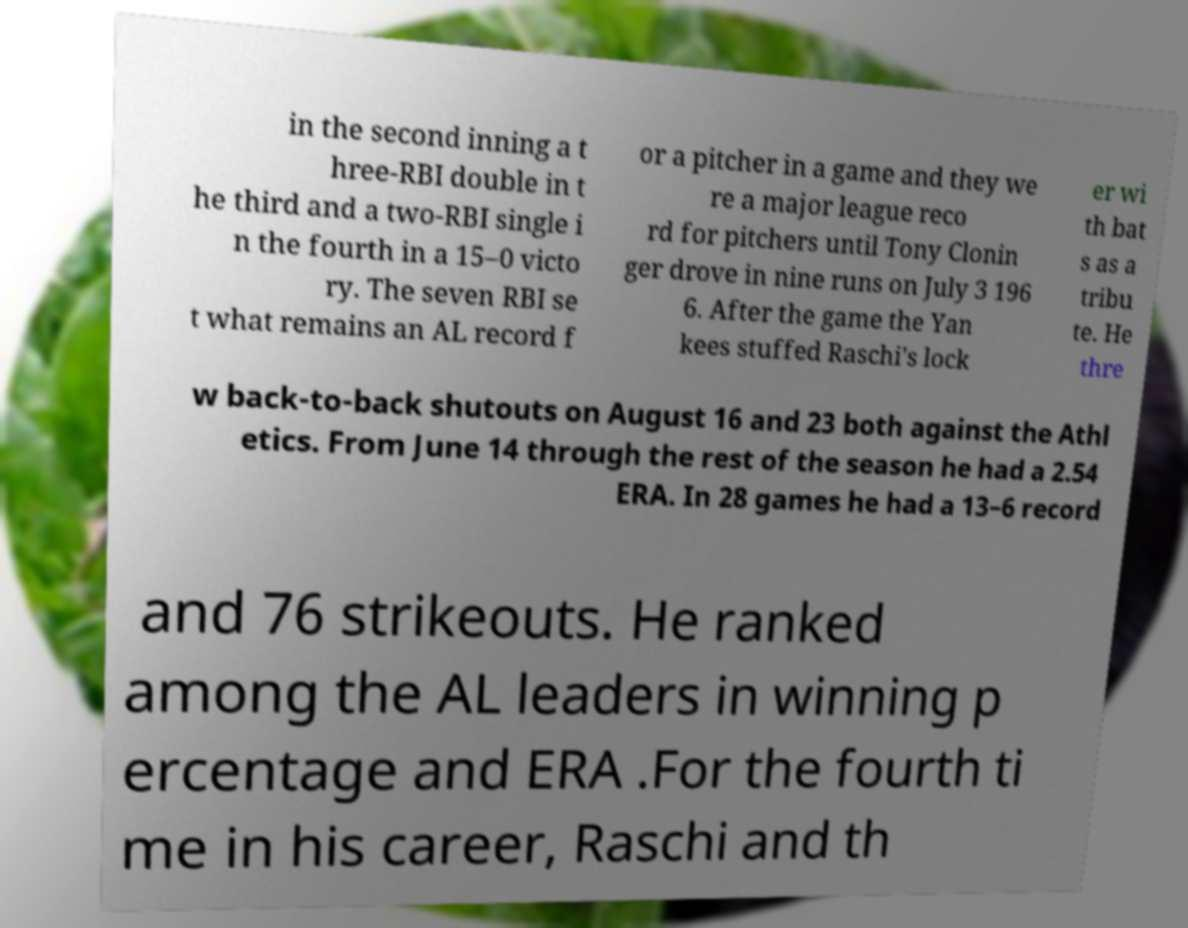Can you accurately transcribe the text from the provided image for me? in the second inning a t hree-RBI double in t he third and a two-RBI single i n the fourth in a 15–0 victo ry. The seven RBI se t what remains an AL record f or a pitcher in a game and they we re a major league reco rd for pitchers until Tony Clonin ger drove in nine runs on July 3 196 6. After the game the Yan kees stuffed Raschi's lock er wi th bat s as a tribu te. He thre w back-to-back shutouts on August 16 and 23 both against the Athl etics. From June 14 through the rest of the season he had a 2.54 ERA. In 28 games he had a 13–6 record and 76 strikeouts. He ranked among the AL leaders in winning p ercentage and ERA .For the fourth ti me in his career, Raschi and th 